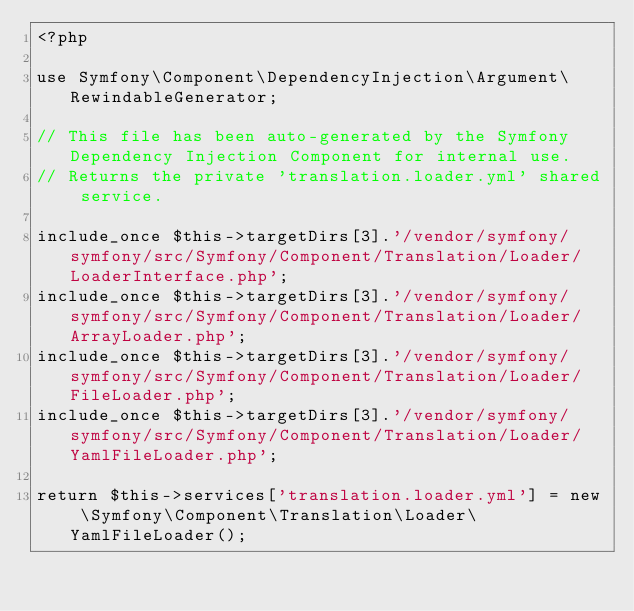<code> <loc_0><loc_0><loc_500><loc_500><_PHP_><?php

use Symfony\Component\DependencyInjection\Argument\RewindableGenerator;

// This file has been auto-generated by the Symfony Dependency Injection Component for internal use.
// Returns the private 'translation.loader.yml' shared service.

include_once $this->targetDirs[3].'/vendor/symfony/symfony/src/Symfony/Component/Translation/Loader/LoaderInterface.php';
include_once $this->targetDirs[3].'/vendor/symfony/symfony/src/Symfony/Component/Translation/Loader/ArrayLoader.php';
include_once $this->targetDirs[3].'/vendor/symfony/symfony/src/Symfony/Component/Translation/Loader/FileLoader.php';
include_once $this->targetDirs[3].'/vendor/symfony/symfony/src/Symfony/Component/Translation/Loader/YamlFileLoader.php';

return $this->services['translation.loader.yml'] = new \Symfony\Component\Translation\Loader\YamlFileLoader();
</code> 